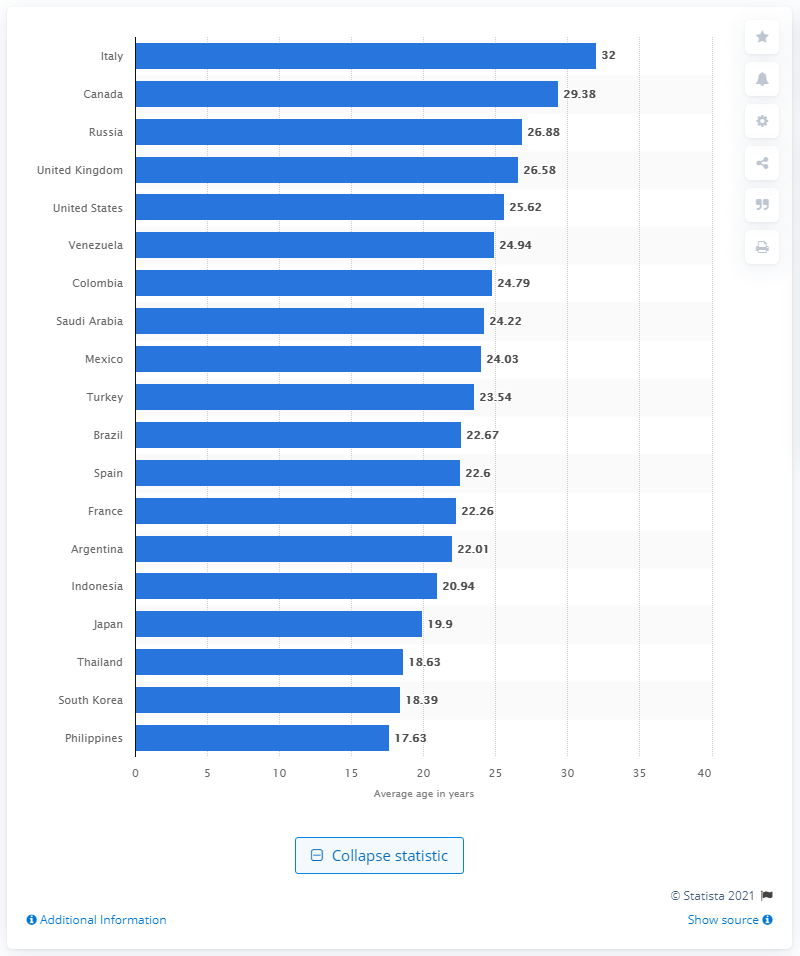Outline some significant characteristics in this image. South Korea had the second-youngest Twitter user base as of October 2013, with the majority of its users being under the age of 35. 